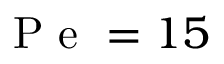Convert formula to latex. <formula><loc_0><loc_0><loc_500><loc_500>P e = 1 5</formula> 